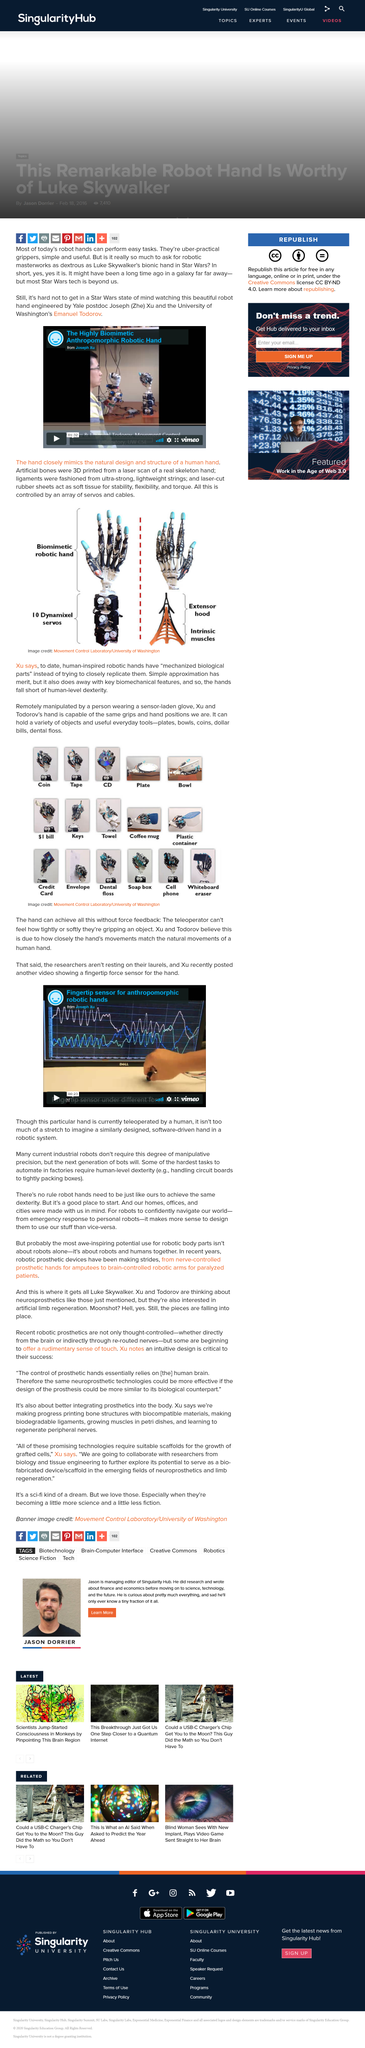Indicate a few pertinent items in this graphic. The artificial bones, ligaments, and rubber sheets are controlled by an array of servos and cables. According to experts, robotic hands with "mechanised biological parts" may have limitations in achieving the same level of dexterity as human hands. Although simple approximations can be useful, they also eliminate key biomechanical features, resulting in a less capable performance. A recent video posted by Joseph Xu showcases a fingertip force sensor for the hand, highlighting its capabilities and potential applications. The anthropomorphic robotic hand was engineered by Joseph (The) Cu and Emanuel Todorov. The artificial bones of the robotic hand were 3D printed using a laser scan of a real skeleton hand as the model. 